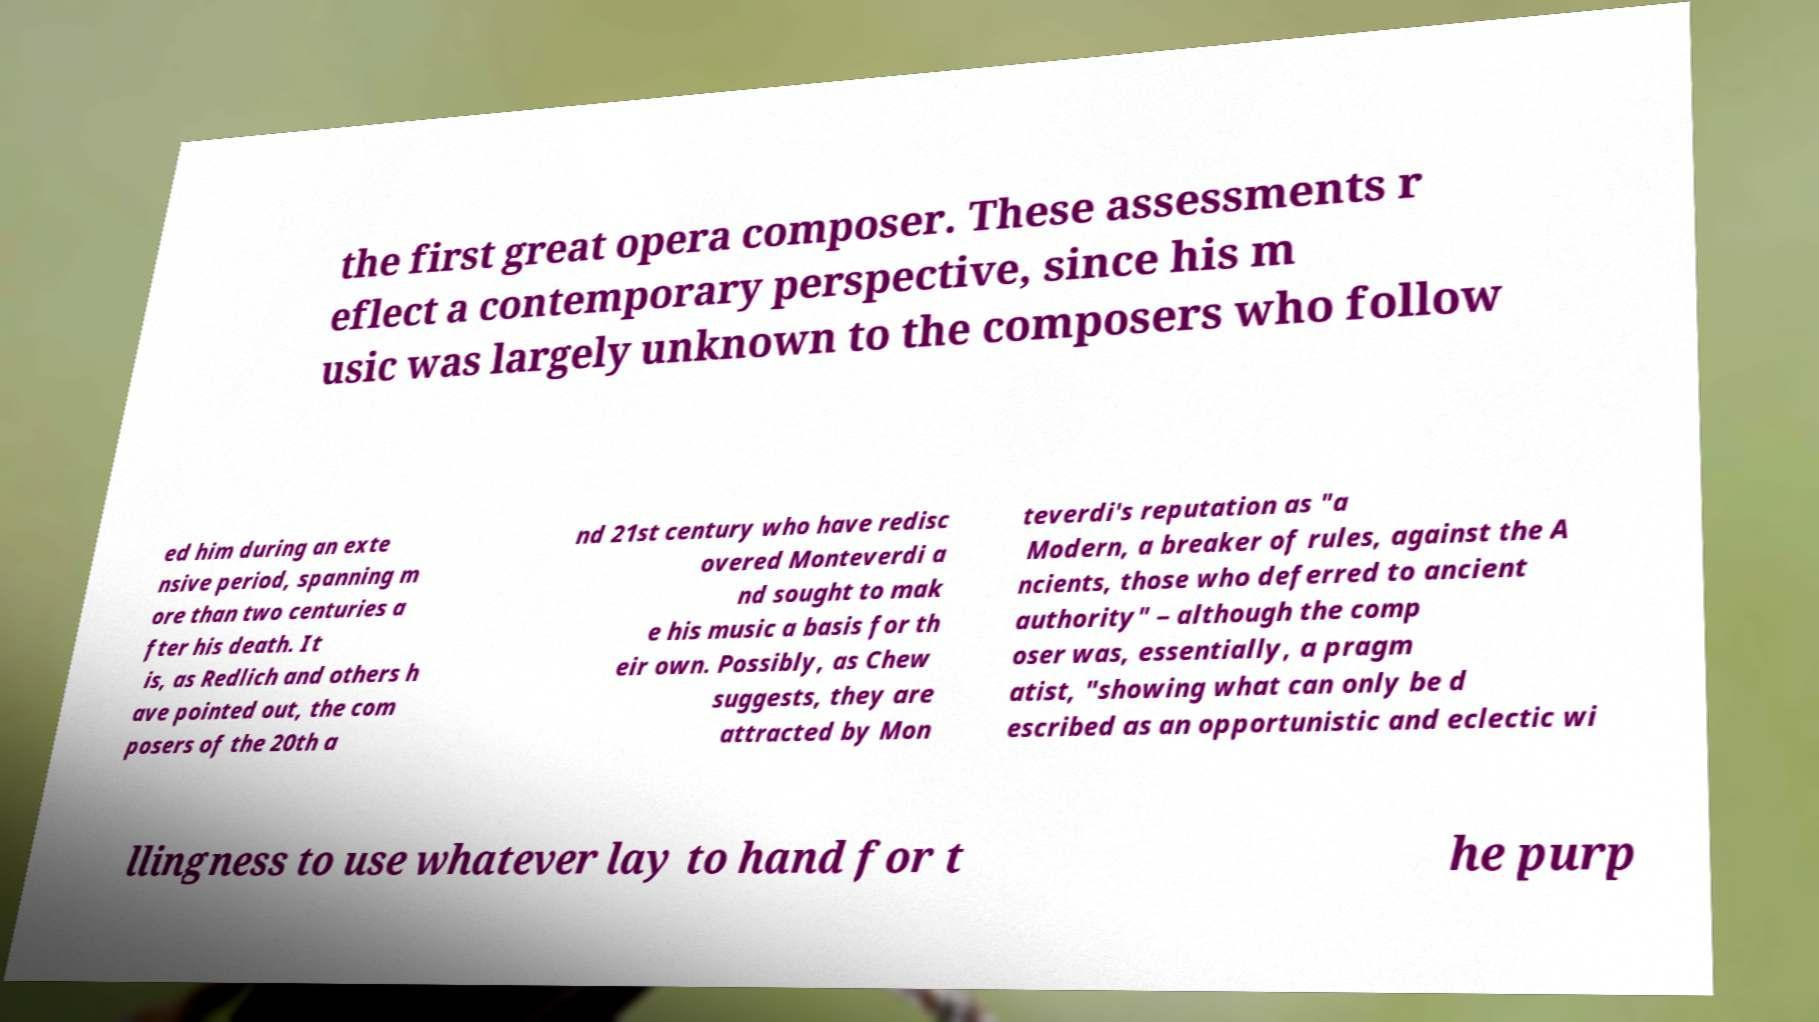What messages or text are displayed in this image? I need them in a readable, typed format. the first great opera composer. These assessments r eflect a contemporary perspective, since his m usic was largely unknown to the composers who follow ed him during an exte nsive period, spanning m ore than two centuries a fter his death. It is, as Redlich and others h ave pointed out, the com posers of the 20th a nd 21st century who have redisc overed Monteverdi a nd sought to mak e his music a basis for th eir own. Possibly, as Chew suggests, they are attracted by Mon teverdi's reputation as "a Modern, a breaker of rules, against the A ncients, those who deferred to ancient authority" – although the comp oser was, essentially, a pragm atist, "showing what can only be d escribed as an opportunistic and eclectic wi llingness to use whatever lay to hand for t he purp 